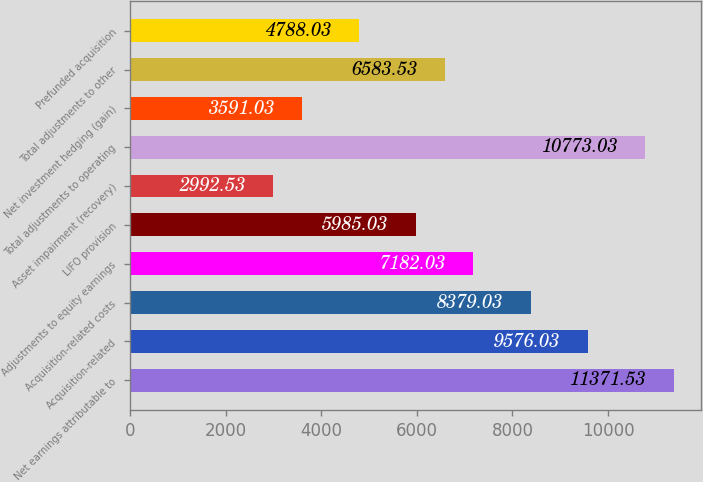Convert chart to OTSL. <chart><loc_0><loc_0><loc_500><loc_500><bar_chart><fcel>Net earnings attributable to<fcel>Acquisition-related<fcel>Acquisition-related costs<fcel>Adjustments to equity earnings<fcel>LIFO provision<fcel>Asset impairment (recovery)<fcel>Total adjustments to operating<fcel>Net investment hedging (gain)<fcel>Total adjustments to other<fcel>Prefunded acquisition<nl><fcel>11371.5<fcel>9576.03<fcel>8379.03<fcel>7182.03<fcel>5985.03<fcel>2992.53<fcel>10773<fcel>3591.03<fcel>6583.53<fcel>4788.03<nl></chart> 